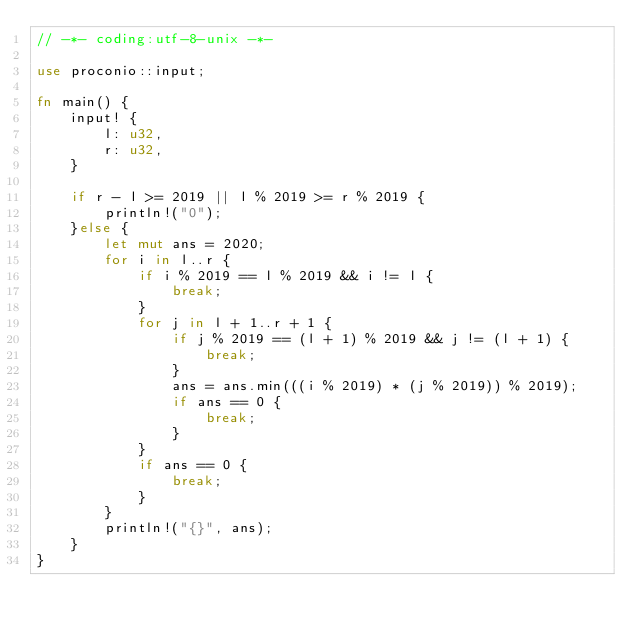<code> <loc_0><loc_0><loc_500><loc_500><_Rust_>// -*- coding:utf-8-unix -*-

use proconio::input;

fn main() {
    input! {
        l: u32,
        r: u32,
    }

    if r - l >= 2019 || l % 2019 >= r % 2019 {
        println!("0");
    }else {
        let mut ans = 2020;
        for i in l..r {
            if i % 2019 == l % 2019 && i != l {
                break;
            }
            for j in l + 1..r + 1 {
                if j % 2019 == (l + 1) % 2019 && j != (l + 1) {
                    break;
                }
                ans = ans.min(((i % 2019) * (j % 2019)) % 2019);
                if ans == 0 {
                    break;
                }
            }
            if ans == 0 {
                break;
            }
        }
        println!("{}", ans);
    }
}
</code> 